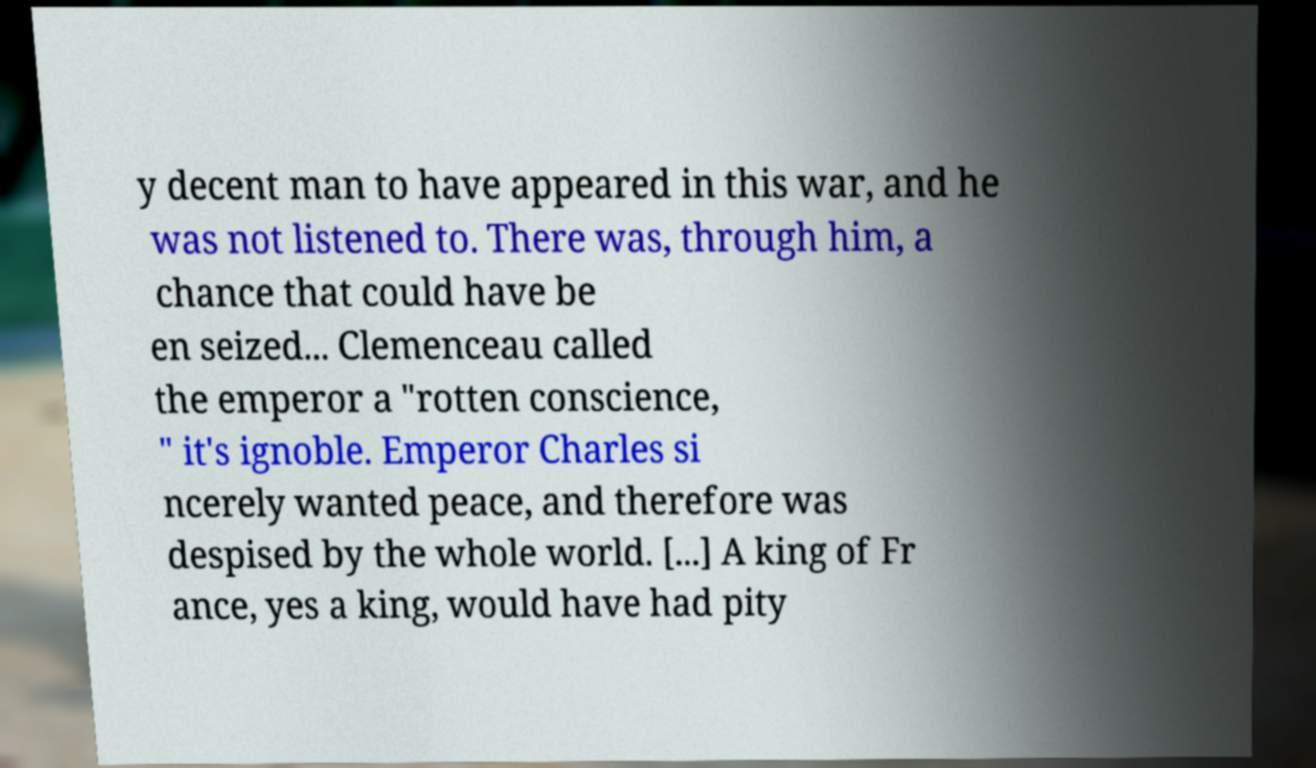Can you accurately transcribe the text from the provided image for me? y decent man to have appeared in this war, and he was not listened to. There was, through him, a chance that could have be en seized... Clemenceau called the emperor a "rotten conscience, " it's ignoble. Emperor Charles si ncerely wanted peace, and therefore was despised by the whole world. [...] A king of Fr ance, yes a king, would have had pity 